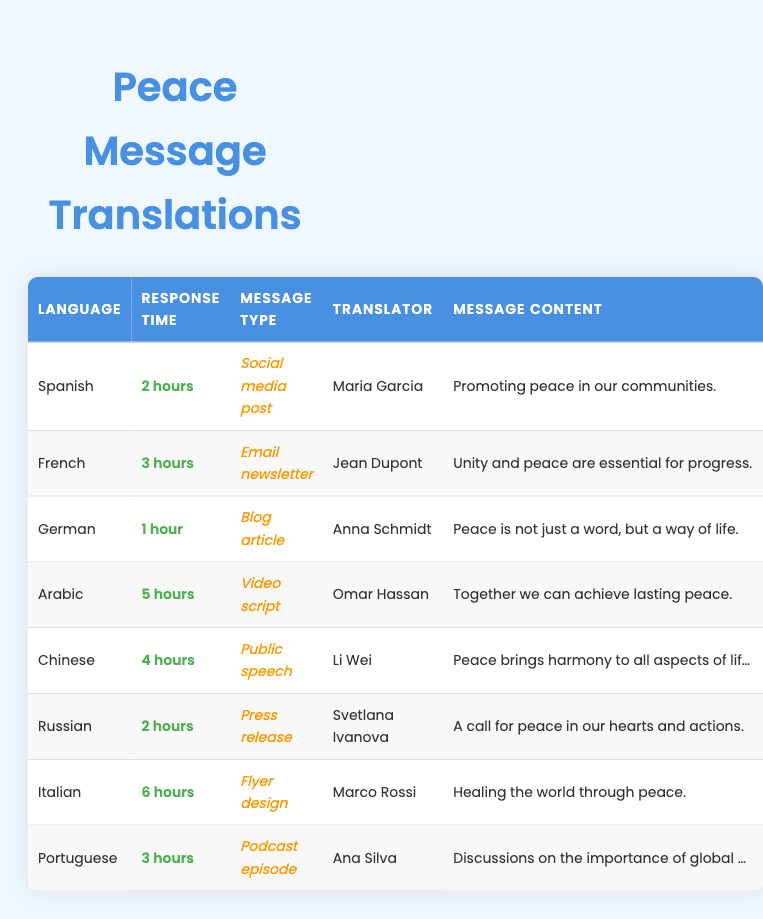What is the fastest response time for a translation? The table shows the response times for translations, and the lowest time listed is 1 hour for the German translation.
Answer: 1 hour Which translator took the longest to respond? By scanning the response times, we see that the longest time is 6 hours for the Italian translation done by Marco Rossi.
Answer: Marco Rossi What is the average response time for all translations? To find the average, we first add up all the response times: (2 + 3 + 1 + 5 + 4 + 2 + 6 + 3) = 26 hours. Then we divide by the number of translations (8): 26/8 = 3.25 hours.
Answer: 3.25 hours Is Maria Garcia the only translator with a response time of 2 hours? The table lists both Maria Garcia for Spanish and Svetlana Ivanova for Russian, both with a response time of 2 hours. Therefore, the statement is false.
Answer: No Which languages have a response time greater than 3 hours? By examining the table, the languages that show a response time greater than 3 hours are Arabic (5 hours) and Italian (6 hours).
Answer: Arabic, Italian How many translations were completed by the same translator name? The table shows that each translator appears only once for their respective languages, meaning no translator completed more than one translation.
Answer: None Who translated the public speech and how long did it take? The public speech was translated into Chinese by Li Wei, with a response time of 4 hours.
Answer: Li Wei, 4 hours What is the total response time for translations related to social media and emails? First, we identify the translations for social media (Spanish, 2 hours) and email (French, 3 hours). We sum these times: 2 + 3 = 5 hours.
Answer: 5 hours Which message type took the least amount of time to translate? Looking through the table, the blog article translation took 1 hour, which is the least time compared to others.
Answer: Blog article 